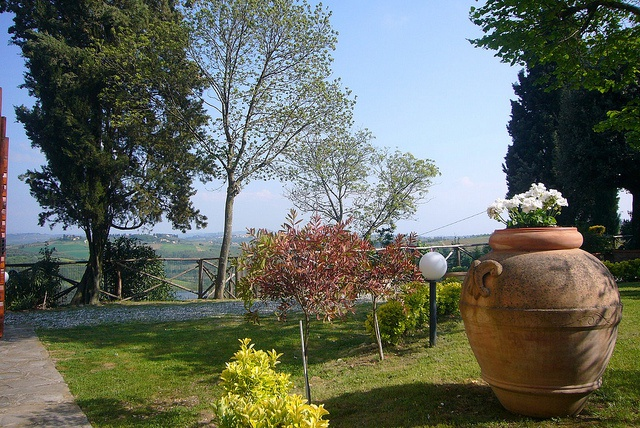Describe the objects in this image and their specific colors. I can see potted plant in black, maroon, and gray tones and vase in black, maroon, and gray tones in this image. 